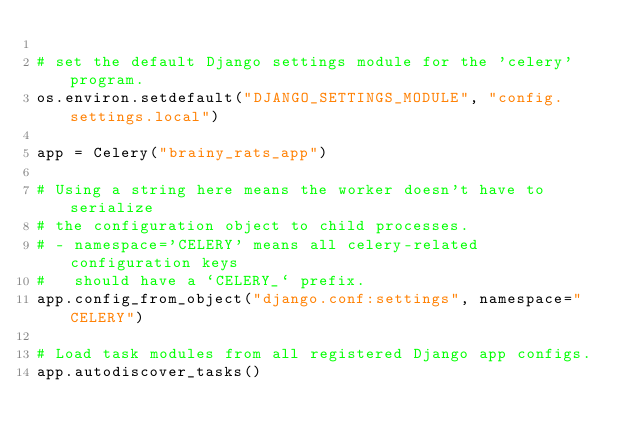<code> <loc_0><loc_0><loc_500><loc_500><_Python_>
# set the default Django settings module for the 'celery' program.
os.environ.setdefault("DJANGO_SETTINGS_MODULE", "config.settings.local")

app = Celery("brainy_rats_app")

# Using a string here means the worker doesn't have to serialize
# the configuration object to child processes.
# - namespace='CELERY' means all celery-related configuration keys
#   should have a `CELERY_` prefix.
app.config_from_object("django.conf:settings", namespace="CELERY")

# Load task modules from all registered Django app configs.
app.autodiscover_tasks()
</code> 